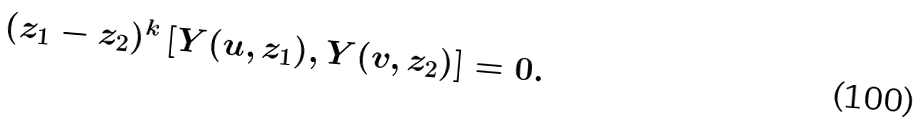<formula> <loc_0><loc_0><loc_500><loc_500>( z _ { 1 } - z _ { 2 } ) ^ { k } \left [ Y ( u , z _ { 1 } ) , Y ( v , z _ { 2 } ) \right ] = 0 .</formula> 